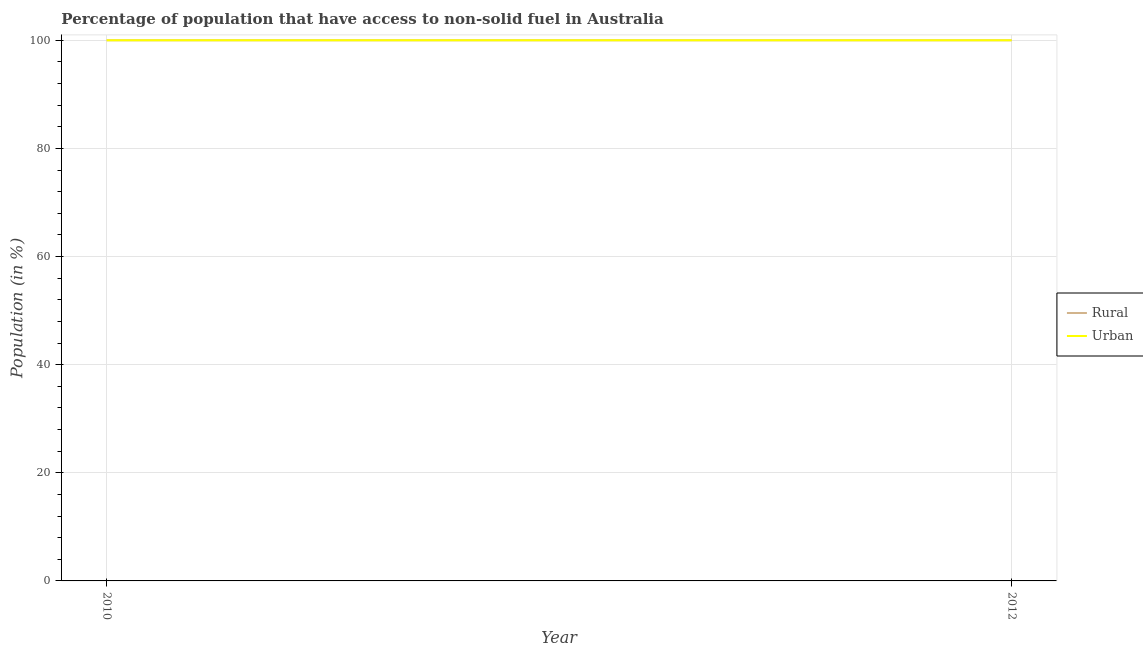How many different coloured lines are there?
Provide a short and direct response. 2. Is the number of lines equal to the number of legend labels?
Make the answer very short. Yes. What is the urban population in 2012?
Offer a terse response. 100. Across all years, what is the maximum rural population?
Make the answer very short. 100. Across all years, what is the minimum rural population?
Your answer should be compact. 100. In which year was the urban population maximum?
Offer a very short reply. 2010. In which year was the rural population minimum?
Keep it short and to the point. 2010. What is the total rural population in the graph?
Ensure brevity in your answer.  200. What is the average rural population per year?
Offer a very short reply. 100. In the year 2012, what is the difference between the rural population and urban population?
Keep it short and to the point. 0. In how many years, is the rural population greater than 36 %?
Ensure brevity in your answer.  2. Is the rural population in 2010 less than that in 2012?
Your answer should be compact. No. In how many years, is the rural population greater than the average rural population taken over all years?
Ensure brevity in your answer.  0. Is the rural population strictly greater than the urban population over the years?
Provide a succinct answer. No. Is the urban population strictly less than the rural population over the years?
Your answer should be very brief. No. Does the graph contain grids?
Your response must be concise. Yes. How many legend labels are there?
Ensure brevity in your answer.  2. What is the title of the graph?
Your answer should be very brief. Percentage of population that have access to non-solid fuel in Australia. What is the label or title of the X-axis?
Make the answer very short. Year. What is the label or title of the Y-axis?
Provide a short and direct response. Population (in %). What is the Population (in %) in Rural in 2010?
Keep it short and to the point. 100. What is the Population (in %) of Rural in 2012?
Keep it short and to the point. 100. What is the Population (in %) of Urban in 2012?
Keep it short and to the point. 100. Across all years, what is the maximum Population (in %) in Rural?
Your answer should be compact. 100. Across all years, what is the maximum Population (in %) in Urban?
Your answer should be very brief. 100. What is the difference between the Population (in %) in Rural in 2010 and that in 2012?
Give a very brief answer. 0. What is the difference between the Population (in %) in Urban in 2010 and that in 2012?
Ensure brevity in your answer.  0. What is the average Population (in %) in Rural per year?
Your answer should be very brief. 100. In the year 2010, what is the difference between the Population (in %) of Rural and Population (in %) of Urban?
Your answer should be compact. 0. In the year 2012, what is the difference between the Population (in %) in Rural and Population (in %) in Urban?
Offer a very short reply. 0. What is the ratio of the Population (in %) in Rural in 2010 to that in 2012?
Ensure brevity in your answer.  1. What is the ratio of the Population (in %) in Urban in 2010 to that in 2012?
Make the answer very short. 1. What is the difference between the highest and the lowest Population (in %) of Urban?
Ensure brevity in your answer.  0. 